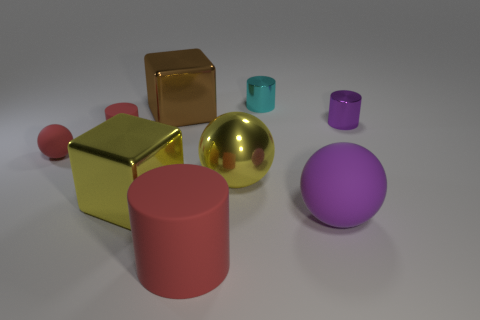Subtract all purple metallic cylinders. How many cylinders are left? 3 Add 1 purple cylinders. How many purple cylinders are left? 2 Add 1 red rubber cylinders. How many red rubber cylinders exist? 3 Subtract all red spheres. How many spheres are left? 2 Subtract 0 blue blocks. How many objects are left? 9 Subtract all cubes. How many objects are left? 7 Subtract 3 balls. How many balls are left? 0 Subtract all red balls. Subtract all green cylinders. How many balls are left? 2 Subtract all purple blocks. How many yellow balls are left? 1 Subtract all gray objects. Subtract all cyan metallic cylinders. How many objects are left? 8 